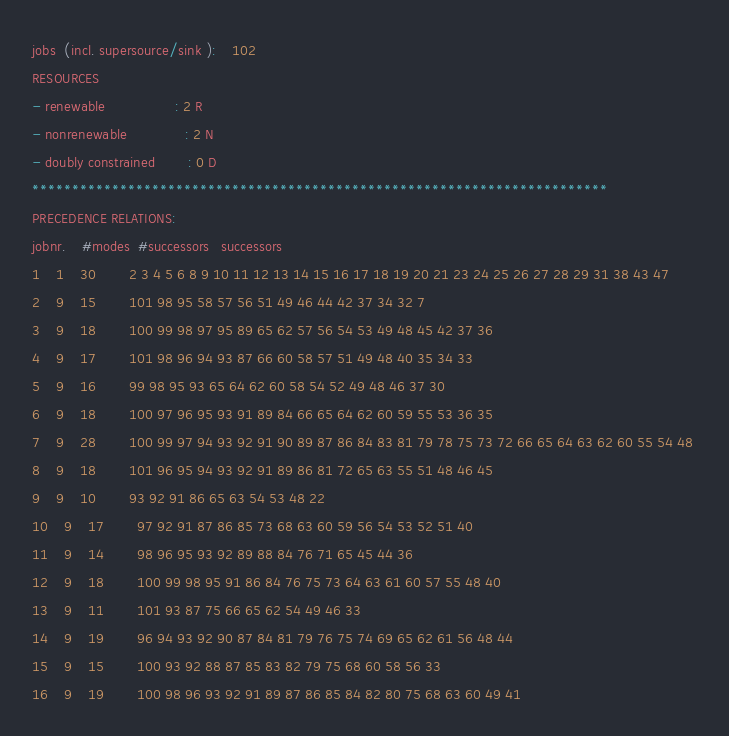Convert code to text. <code><loc_0><loc_0><loc_500><loc_500><_ObjectiveC_>jobs  (incl. supersource/sink ):	102
RESOURCES
- renewable                 : 2 R
- nonrenewable              : 2 N
- doubly constrained        : 0 D
************************************************************************
PRECEDENCE RELATIONS:
jobnr.    #modes  #successors   successors
1	1	30		2 3 4 5 6 8 9 10 11 12 13 14 15 16 17 18 19 20 21 23 24 25 26 27 28 29 31 38 43 47 
2	9	15		101 98 95 58 57 56 51 49 46 44 42 37 34 32 7 
3	9	18		100 99 98 97 95 89 65 62 57 56 54 53 49 48 45 42 37 36 
4	9	17		101 98 96 94 93 87 66 60 58 57 51 49 48 40 35 34 33 
5	9	16		99 98 95 93 65 64 62 60 58 54 52 49 48 46 37 30 
6	9	18		100 97 96 95 93 91 89 84 66 65 64 62 60 59 55 53 36 35 
7	9	28		100 99 97 94 93 92 91 90 89 87 86 84 83 81 79 78 75 73 72 66 65 64 63 62 60 55 54 48 
8	9	18		101 96 95 94 93 92 91 89 86 81 72 65 63 55 51 48 46 45 
9	9	10		93 92 91 86 65 63 54 53 48 22 
10	9	17		97 92 91 87 86 85 73 68 63 60 59 56 54 53 52 51 40 
11	9	14		98 96 95 93 92 89 88 84 76 71 65 45 44 36 
12	9	18		100 99 98 95 91 86 84 76 75 73 64 63 61 60 57 55 48 40 
13	9	11		101 93 87 75 66 65 62 54 49 46 33 
14	9	19		96 94 93 92 90 87 84 81 79 76 75 74 69 65 62 61 56 48 44 
15	9	15		100 93 92 88 87 85 83 82 79 75 68 60 58 56 33 
16	9	19		100 98 96 93 92 91 89 87 86 85 84 82 80 75 68 63 60 49 41 </code> 